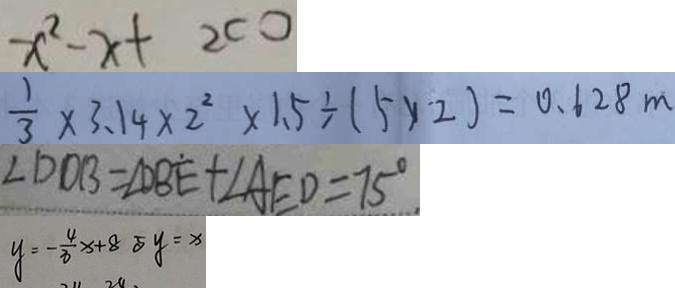Convert formula to latex. <formula><loc_0><loc_0><loc_500><loc_500>x ^ { 2 } - x + 2 c 0 
 \frac { 1 } { 3 } \times 3 . 1 4 \times 2 ^ { 2 } \times 1 . 5 \div ( 5 \times 2 ) = 0 . 6 2 8 m 
 \angle D D B = \angle D B E + \angle A E D = 7 5 ^ { \circ } . 
 y = - \frac { 4 } { 3 } x + 8 5 y = x</formula> 